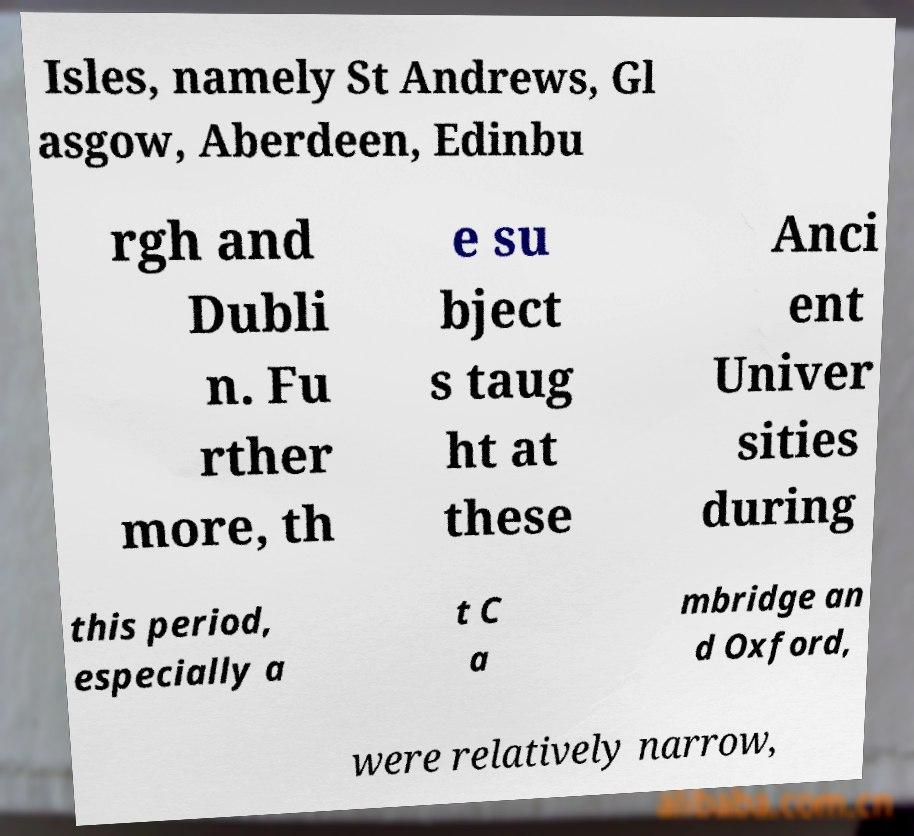Can you read and provide the text displayed in the image?This photo seems to have some interesting text. Can you extract and type it out for me? Isles, namely St Andrews, Gl asgow, Aberdeen, Edinbu rgh and Dubli n. Fu rther more, th e su bject s taug ht at these Anci ent Univer sities during this period, especially a t C a mbridge an d Oxford, were relatively narrow, 